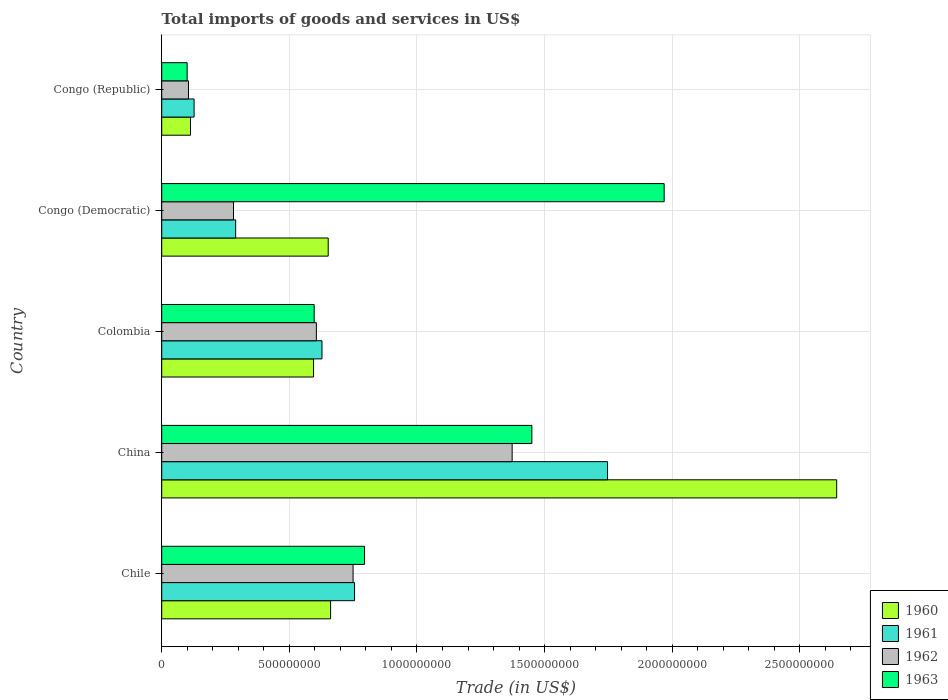How many different coloured bars are there?
Provide a short and direct response. 4. Are the number of bars on each tick of the Y-axis equal?
Provide a short and direct response. Yes. How many bars are there on the 5th tick from the top?
Provide a succinct answer. 4. What is the label of the 1st group of bars from the top?
Give a very brief answer. Congo (Republic). What is the total imports of goods and services in 1961 in China?
Make the answer very short. 1.75e+09. Across all countries, what is the maximum total imports of goods and services in 1963?
Your answer should be very brief. 1.97e+09. Across all countries, what is the minimum total imports of goods and services in 1963?
Offer a terse response. 9.96e+07. In which country was the total imports of goods and services in 1963 minimum?
Keep it short and to the point. Congo (Republic). What is the total total imports of goods and services in 1963 in the graph?
Your response must be concise. 4.91e+09. What is the difference between the total imports of goods and services in 1962 in Colombia and that in Congo (Democratic)?
Provide a succinct answer. 3.25e+08. What is the difference between the total imports of goods and services in 1962 in Congo (Democratic) and the total imports of goods and services in 1961 in Colombia?
Provide a succinct answer. -3.47e+08. What is the average total imports of goods and services in 1961 per country?
Your response must be concise. 7.09e+08. What is the difference between the total imports of goods and services in 1960 and total imports of goods and services in 1962 in Chile?
Offer a terse response. -8.81e+07. What is the ratio of the total imports of goods and services in 1962 in China to that in Congo (Republic)?
Provide a succinct answer. 13.1. Is the total imports of goods and services in 1962 in Congo (Democratic) less than that in Congo (Republic)?
Keep it short and to the point. No. What is the difference between the highest and the second highest total imports of goods and services in 1960?
Give a very brief answer. 1.98e+09. What is the difference between the highest and the lowest total imports of goods and services in 1963?
Provide a succinct answer. 1.87e+09. In how many countries, is the total imports of goods and services in 1963 greater than the average total imports of goods and services in 1963 taken over all countries?
Make the answer very short. 2. Is the sum of the total imports of goods and services in 1960 in China and Colombia greater than the maximum total imports of goods and services in 1963 across all countries?
Your answer should be very brief. Yes. What does the 4th bar from the top in Colombia represents?
Keep it short and to the point. 1960. What does the 3rd bar from the bottom in Chile represents?
Offer a terse response. 1962. Is it the case that in every country, the sum of the total imports of goods and services in 1963 and total imports of goods and services in 1960 is greater than the total imports of goods and services in 1961?
Keep it short and to the point. Yes. How many bars are there?
Your answer should be very brief. 20. What is the difference between two consecutive major ticks on the X-axis?
Keep it short and to the point. 5.00e+08. Does the graph contain any zero values?
Offer a terse response. No. Does the graph contain grids?
Offer a very short reply. Yes. How many legend labels are there?
Ensure brevity in your answer.  4. How are the legend labels stacked?
Your answer should be very brief. Vertical. What is the title of the graph?
Offer a very short reply. Total imports of goods and services in US$. Does "2002" appear as one of the legend labels in the graph?
Your answer should be compact. No. What is the label or title of the X-axis?
Keep it short and to the point. Trade (in US$). What is the Trade (in US$) in 1960 in Chile?
Ensure brevity in your answer.  6.62e+08. What is the Trade (in US$) of 1961 in Chile?
Your answer should be very brief. 7.55e+08. What is the Trade (in US$) of 1962 in Chile?
Your answer should be very brief. 7.50e+08. What is the Trade (in US$) in 1963 in Chile?
Your answer should be very brief. 7.95e+08. What is the Trade (in US$) in 1960 in China?
Ensure brevity in your answer.  2.64e+09. What is the Trade (in US$) of 1961 in China?
Your answer should be very brief. 1.75e+09. What is the Trade (in US$) of 1962 in China?
Your response must be concise. 1.37e+09. What is the Trade (in US$) in 1963 in China?
Your answer should be very brief. 1.45e+09. What is the Trade (in US$) of 1960 in Colombia?
Provide a short and direct response. 5.95e+08. What is the Trade (in US$) of 1961 in Colombia?
Make the answer very short. 6.28e+08. What is the Trade (in US$) of 1962 in Colombia?
Make the answer very short. 6.06e+08. What is the Trade (in US$) of 1963 in Colombia?
Provide a short and direct response. 5.97e+08. What is the Trade (in US$) in 1960 in Congo (Democratic)?
Offer a very short reply. 6.52e+08. What is the Trade (in US$) in 1961 in Congo (Democratic)?
Make the answer very short. 2.90e+08. What is the Trade (in US$) in 1962 in Congo (Democratic)?
Keep it short and to the point. 2.81e+08. What is the Trade (in US$) in 1963 in Congo (Democratic)?
Your answer should be compact. 1.97e+09. What is the Trade (in US$) of 1960 in Congo (Republic)?
Your answer should be compact. 1.13e+08. What is the Trade (in US$) of 1961 in Congo (Republic)?
Provide a short and direct response. 1.27e+08. What is the Trade (in US$) in 1962 in Congo (Republic)?
Keep it short and to the point. 1.05e+08. What is the Trade (in US$) in 1963 in Congo (Republic)?
Offer a very short reply. 9.96e+07. Across all countries, what is the maximum Trade (in US$) of 1960?
Your answer should be very brief. 2.64e+09. Across all countries, what is the maximum Trade (in US$) of 1961?
Ensure brevity in your answer.  1.75e+09. Across all countries, what is the maximum Trade (in US$) of 1962?
Offer a very short reply. 1.37e+09. Across all countries, what is the maximum Trade (in US$) of 1963?
Provide a succinct answer. 1.97e+09. Across all countries, what is the minimum Trade (in US$) of 1960?
Your response must be concise. 1.13e+08. Across all countries, what is the minimum Trade (in US$) of 1961?
Offer a very short reply. 1.27e+08. Across all countries, what is the minimum Trade (in US$) in 1962?
Ensure brevity in your answer.  1.05e+08. Across all countries, what is the minimum Trade (in US$) in 1963?
Give a very brief answer. 9.96e+07. What is the total Trade (in US$) in 1960 in the graph?
Your answer should be very brief. 4.67e+09. What is the total Trade (in US$) in 1961 in the graph?
Provide a short and direct response. 3.55e+09. What is the total Trade (in US$) of 1962 in the graph?
Provide a short and direct response. 3.11e+09. What is the total Trade (in US$) of 1963 in the graph?
Your answer should be compact. 4.91e+09. What is the difference between the Trade (in US$) of 1960 in Chile and that in China?
Provide a succinct answer. -1.98e+09. What is the difference between the Trade (in US$) of 1961 in Chile and that in China?
Your response must be concise. -9.91e+08. What is the difference between the Trade (in US$) in 1962 in Chile and that in China?
Provide a succinct answer. -6.23e+08. What is the difference between the Trade (in US$) in 1963 in Chile and that in China?
Give a very brief answer. -6.55e+08. What is the difference between the Trade (in US$) in 1960 in Chile and that in Colombia?
Make the answer very short. 6.68e+07. What is the difference between the Trade (in US$) of 1961 in Chile and that in Colombia?
Make the answer very short. 1.28e+08. What is the difference between the Trade (in US$) of 1962 in Chile and that in Colombia?
Your answer should be very brief. 1.44e+08. What is the difference between the Trade (in US$) in 1963 in Chile and that in Colombia?
Make the answer very short. 1.97e+08. What is the difference between the Trade (in US$) of 1960 in Chile and that in Congo (Democratic)?
Your answer should be compact. 9.37e+06. What is the difference between the Trade (in US$) in 1961 in Chile and that in Congo (Democratic)?
Give a very brief answer. 4.66e+08. What is the difference between the Trade (in US$) in 1962 in Chile and that in Congo (Democratic)?
Give a very brief answer. 4.68e+08. What is the difference between the Trade (in US$) in 1963 in Chile and that in Congo (Democratic)?
Offer a terse response. -1.17e+09. What is the difference between the Trade (in US$) of 1960 in Chile and that in Congo (Republic)?
Your response must be concise. 5.49e+08. What is the difference between the Trade (in US$) of 1961 in Chile and that in Congo (Republic)?
Ensure brevity in your answer.  6.29e+08. What is the difference between the Trade (in US$) in 1962 in Chile and that in Congo (Republic)?
Provide a succinct answer. 6.45e+08. What is the difference between the Trade (in US$) in 1963 in Chile and that in Congo (Republic)?
Ensure brevity in your answer.  6.95e+08. What is the difference between the Trade (in US$) of 1960 in China and that in Colombia?
Offer a very short reply. 2.05e+09. What is the difference between the Trade (in US$) of 1961 in China and that in Colombia?
Provide a succinct answer. 1.12e+09. What is the difference between the Trade (in US$) in 1962 in China and that in Colombia?
Give a very brief answer. 7.67e+08. What is the difference between the Trade (in US$) in 1963 in China and that in Colombia?
Your answer should be compact. 8.53e+08. What is the difference between the Trade (in US$) of 1960 in China and that in Congo (Democratic)?
Make the answer very short. 1.99e+09. What is the difference between the Trade (in US$) in 1961 in China and that in Congo (Democratic)?
Offer a terse response. 1.46e+09. What is the difference between the Trade (in US$) of 1962 in China and that in Congo (Democratic)?
Keep it short and to the point. 1.09e+09. What is the difference between the Trade (in US$) of 1963 in China and that in Congo (Democratic)?
Your response must be concise. -5.18e+08. What is the difference between the Trade (in US$) in 1960 in China and that in Congo (Republic)?
Provide a short and direct response. 2.53e+09. What is the difference between the Trade (in US$) in 1961 in China and that in Congo (Republic)?
Keep it short and to the point. 1.62e+09. What is the difference between the Trade (in US$) of 1962 in China and that in Congo (Republic)?
Provide a short and direct response. 1.27e+09. What is the difference between the Trade (in US$) of 1963 in China and that in Congo (Republic)?
Offer a terse response. 1.35e+09. What is the difference between the Trade (in US$) in 1960 in Colombia and that in Congo (Democratic)?
Offer a terse response. -5.74e+07. What is the difference between the Trade (in US$) in 1961 in Colombia and that in Congo (Democratic)?
Offer a very short reply. 3.38e+08. What is the difference between the Trade (in US$) of 1962 in Colombia and that in Congo (Democratic)?
Your answer should be very brief. 3.25e+08. What is the difference between the Trade (in US$) in 1963 in Colombia and that in Congo (Democratic)?
Keep it short and to the point. -1.37e+09. What is the difference between the Trade (in US$) of 1960 in Colombia and that in Congo (Republic)?
Provide a short and direct response. 4.82e+08. What is the difference between the Trade (in US$) of 1961 in Colombia and that in Congo (Republic)?
Provide a short and direct response. 5.01e+08. What is the difference between the Trade (in US$) in 1962 in Colombia and that in Congo (Republic)?
Your answer should be compact. 5.01e+08. What is the difference between the Trade (in US$) in 1963 in Colombia and that in Congo (Republic)?
Your answer should be very brief. 4.98e+08. What is the difference between the Trade (in US$) of 1960 in Congo (Democratic) and that in Congo (Republic)?
Give a very brief answer. 5.40e+08. What is the difference between the Trade (in US$) of 1961 in Congo (Democratic) and that in Congo (Republic)?
Provide a succinct answer. 1.63e+08. What is the difference between the Trade (in US$) in 1962 in Congo (Democratic) and that in Congo (Republic)?
Your answer should be very brief. 1.76e+08. What is the difference between the Trade (in US$) of 1963 in Congo (Democratic) and that in Congo (Republic)?
Provide a succinct answer. 1.87e+09. What is the difference between the Trade (in US$) in 1960 in Chile and the Trade (in US$) in 1961 in China?
Your answer should be very brief. -1.09e+09. What is the difference between the Trade (in US$) in 1960 in Chile and the Trade (in US$) in 1962 in China?
Provide a succinct answer. -7.11e+08. What is the difference between the Trade (in US$) of 1960 in Chile and the Trade (in US$) of 1963 in China?
Ensure brevity in your answer.  -7.88e+08. What is the difference between the Trade (in US$) of 1961 in Chile and the Trade (in US$) of 1962 in China?
Make the answer very short. -6.18e+08. What is the difference between the Trade (in US$) of 1961 in Chile and the Trade (in US$) of 1963 in China?
Ensure brevity in your answer.  -6.95e+08. What is the difference between the Trade (in US$) in 1962 in Chile and the Trade (in US$) in 1963 in China?
Provide a short and direct response. -7.00e+08. What is the difference between the Trade (in US$) of 1960 in Chile and the Trade (in US$) of 1961 in Colombia?
Offer a very short reply. 3.37e+07. What is the difference between the Trade (in US$) of 1960 in Chile and the Trade (in US$) of 1962 in Colombia?
Your answer should be compact. 5.57e+07. What is the difference between the Trade (in US$) in 1960 in Chile and the Trade (in US$) in 1963 in Colombia?
Provide a short and direct response. 6.44e+07. What is the difference between the Trade (in US$) of 1961 in Chile and the Trade (in US$) of 1962 in Colombia?
Make the answer very short. 1.50e+08. What is the difference between the Trade (in US$) in 1961 in Chile and the Trade (in US$) in 1963 in Colombia?
Ensure brevity in your answer.  1.58e+08. What is the difference between the Trade (in US$) of 1962 in Chile and the Trade (in US$) of 1963 in Colombia?
Your response must be concise. 1.52e+08. What is the difference between the Trade (in US$) of 1960 in Chile and the Trade (in US$) of 1961 in Congo (Democratic)?
Provide a succinct answer. 3.72e+08. What is the difference between the Trade (in US$) of 1960 in Chile and the Trade (in US$) of 1962 in Congo (Democratic)?
Ensure brevity in your answer.  3.80e+08. What is the difference between the Trade (in US$) in 1960 in Chile and the Trade (in US$) in 1963 in Congo (Democratic)?
Your answer should be compact. -1.31e+09. What is the difference between the Trade (in US$) of 1961 in Chile and the Trade (in US$) of 1962 in Congo (Democratic)?
Offer a terse response. 4.74e+08. What is the difference between the Trade (in US$) of 1961 in Chile and the Trade (in US$) of 1963 in Congo (Democratic)?
Make the answer very short. -1.21e+09. What is the difference between the Trade (in US$) in 1962 in Chile and the Trade (in US$) in 1963 in Congo (Democratic)?
Your answer should be very brief. -1.22e+09. What is the difference between the Trade (in US$) in 1960 in Chile and the Trade (in US$) in 1961 in Congo (Republic)?
Your answer should be compact. 5.35e+08. What is the difference between the Trade (in US$) of 1960 in Chile and the Trade (in US$) of 1962 in Congo (Republic)?
Provide a short and direct response. 5.57e+08. What is the difference between the Trade (in US$) of 1960 in Chile and the Trade (in US$) of 1963 in Congo (Republic)?
Make the answer very short. 5.62e+08. What is the difference between the Trade (in US$) of 1961 in Chile and the Trade (in US$) of 1962 in Congo (Republic)?
Your answer should be compact. 6.51e+08. What is the difference between the Trade (in US$) of 1961 in Chile and the Trade (in US$) of 1963 in Congo (Republic)?
Your response must be concise. 6.56e+08. What is the difference between the Trade (in US$) in 1962 in Chile and the Trade (in US$) in 1963 in Congo (Republic)?
Your answer should be compact. 6.50e+08. What is the difference between the Trade (in US$) in 1960 in China and the Trade (in US$) in 1961 in Colombia?
Your response must be concise. 2.02e+09. What is the difference between the Trade (in US$) in 1960 in China and the Trade (in US$) in 1962 in Colombia?
Keep it short and to the point. 2.04e+09. What is the difference between the Trade (in US$) of 1960 in China and the Trade (in US$) of 1963 in Colombia?
Provide a short and direct response. 2.05e+09. What is the difference between the Trade (in US$) in 1961 in China and the Trade (in US$) in 1962 in Colombia?
Keep it short and to the point. 1.14e+09. What is the difference between the Trade (in US$) in 1961 in China and the Trade (in US$) in 1963 in Colombia?
Ensure brevity in your answer.  1.15e+09. What is the difference between the Trade (in US$) of 1962 in China and the Trade (in US$) of 1963 in Colombia?
Keep it short and to the point. 7.76e+08. What is the difference between the Trade (in US$) in 1960 in China and the Trade (in US$) in 1961 in Congo (Democratic)?
Keep it short and to the point. 2.35e+09. What is the difference between the Trade (in US$) in 1960 in China and the Trade (in US$) in 1962 in Congo (Democratic)?
Ensure brevity in your answer.  2.36e+09. What is the difference between the Trade (in US$) in 1960 in China and the Trade (in US$) in 1963 in Congo (Democratic)?
Make the answer very short. 6.76e+08. What is the difference between the Trade (in US$) in 1961 in China and the Trade (in US$) in 1962 in Congo (Democratic)?
Offer a very short reply. 1.47e+09. What is the difference between the Trade (in US$) in 1961 in China and the Trade (in US$) in 1963 in Congo (Democratic)?
Ensure brevity in your answer.  -2.22e+08. What is the difference between the Trade (in US$) of 1962 in China and the Trade (in US$) of 1963 in Congo (Democratic)?
Your response must be concise. -5.96e+08. What is the difference between the Trade (in US$) in 1960 in China and the Trade (in US$) in 1961 in Congo (Republic)?
Provide a short and direct response. 2.52e+09. What is the difference between the Trade (in US$) of 1960 in China and the Trade (in US$) of 1962 in Congo (Republic)?
Provide a succinct answer. 2.54e+09. What is the difference between the Trade (in US$) of 1960 in China and the Trade (in US$) of 1963 in Congo (Republic)?
Ensure brevity in your answer.  2.54e+09. What is the difference between the Trade (in US$) of 1961 in China and the Trade (in US$) of 1962 in Congo (Republic)?
Ensure brevity in your answer.  1.64e+09. What is the difference between the Trade (in US$) of 1961 in China and the Trade (in US$) of 1963 in Congo (Republic)?
Your answer should be compact. 1.65e+09. What is the difference between the Trade (in US$) in 1962 in China and the Trade (in US$) in 1963 in Congo (Republic)?
Provide a short and direct response. 1.27e+09. What is the difference between the Trade (in US$) of 1960 in Colombia and the Trade (in US$) of 1961 in Congo (Democratic)?
Provide a short and direct response. 3.05e+08. What is the difference between the Trade (in US$) in 1960 in Colombia and the Trade (in US$) in 1962 in Congo (Democratic)?
Your response must be concise. 3.14e+08. What is the difference between the Trade (in US$) of 1960 in Colombia and the Trade (in US$) of 1963 in Congo (Democratic)?
Ensure brevity in your answer.  -1.37e+09. What is the difference between the Trade (in US$) of 1961 in Colombia and the Trade (in US$) of 1962 in Congo (Democratic)?
Make the answer very short. 3.47e+08. What is the difference between the Trade (in US$) of 1961 in Colombia and the Trade (in US$) of 1963 in Congo (Democratic)?
Ensure brevity in your answer.  -1.34e+09. What is the difference between the Trade (in US$) in 1962 in Colombia and the Trade (in US$) in 1963 in Congo (Democratic)?
Provide a succinct answer. -1.36e+09. What is the difference between the Trade (in US$) in 1960 in Colombia and the Trade (in US$) in 1961 in Congo (Republic)?
Offer a very short reply. 4.68e+08. What is the difference between the Trade (in US$) of 1960 in Colombia and the Trade (in US$) of 1962 in Congo (Republic)?
Offer a terse response. 4.90e+08. What is the difference between the Trade (in US$) in 1960 in Colombia and the Trade (in US$) in 1963 in Congo (Republic)?
Give a very brief answer. 4.95e+08. What is the difference between the Trade (in US$) in 1961 in Colombia and the Trade (in US$) in 1962 in Congo (Republic)?
Offer a terse response. 5.23e+08. What is the difference between the Trade (in US$) in 1961 in Colombia and the Trade (in US$) in 1963 in Congo (Republic)?
Provide a succinct answer. 5.28e+08. What is the difference between the Trade (in US$) of 1962 in Colombia and the Trade (in US$) of 1963 in Congo (Republic)?
Your answer should be compact. 5.06e+08. What is the difference between the Trade (in US$) in 1960 in Congo (Democratic) and the Trade (in US$) in 1961 in Congo (Republic)?
Ensure brevity in your answer.  5.25e+08. What is the difference between the Trade (in US$) in 1960 in Congo (Democratic) and the Trade (in US$) in 1962 in Congo (Republic)?
Ensure brevity in your answer.  5.47e+08. What is the difference between the Trade (in US$) in 1960 in Congo (Democratic) and the Trade (in US$) in 1963 in Congo (Republic)?
Keep it short and to the point. 5.53e+08. What is the difference between the Trade (in US$) of 1961 in Congo (Democratic) and the Trade (in US$) of 1962 in Congo (Republic)?
Provide a short and direct response. 1.85e+08. What is the difference between the Trade (in US$) of 1961 in Congo (Democratic) and the Trade (in US$) of 1963 in Congo (Republic)?
Give a very brief answer. 1.90e+08. What is the difference between the Trade (in US$) in 1962 in Congo (Democratic) and the Trade (in US$) in 1963 in Congo (Republic)?
Offer a very short reply. 1.82e+08. What is the average Trade (in US$) of 1960 per country?
Your answer should be compact. 9.33e+08. What is the average Trade (in US$) of 1961 per country?
Your response must be concise. 7.09e+08. What is the average Trade (in US$) in 1962 per country?
Make the answer very short. 6.23e+08. What is the average Trade (in US$) of 1963 per country?
Offer a terse response. 9.82e+08. What is the difference between the Trade (in US$) of 1960 and Trade (in US$) of 1961 in Chile?
Provide a short and direct response. -9.38e+07. What is the difference between the Trade (in US$) in 1960 and Trade (in US$) in 1962 in Chile?
Make the answer very short. -8.81e+07. What is the difference between the Trade (in US$) in 1960 and Trade (in US$) in 1963 in Chile?
Offer a terse response. -1.33e+08. What is the difference between the Trade (in US$) of 1961 and Trade (in US$) of 1962 in Chile?
Give a very brief answer. 5.71e+06. What is the difference between the Trade (in US$) of 1961 and Trade (in US$) of 1963 in Chile?
Your response must be concise. -3.92e+07. What is the difference between the Trade (in US$) in 1962 and Trade (in US$) in 1963 in Chile?
Offer a very short reply. -4.50e+07. What is the difference between the Trade (in US$) of 1960 and Trade (in US$) of 1961 in China?
Provide a short and direct response. 8.98e+08. What is the difference between the Trade (in US$) in 1960 and Trade (in US$) in 1962 in China?
Provide a short and direct response. 1.27e+09. What is the difference between the Trade (in US$) in 1960 and Trade (in US$) in 1963 in China?
Provide a succinct answer. 1.19e+09. What is the difference between the Trade (in US$) of 1961 and Trade (in US$) of 1962 in China?
Your answer should be very brief. 3.74e+08. What is the difference between the Trade (in US$) in 1961 and Trade (in US$) in 1963 in China?
Offer a very short reply. 2.97e+08. What is the difference between the Trade (in US$) in 1962 and Trade (in US$) in 1963 in China?
Your response must be concise. -7.72e+07. What is the difference between the Trade (in US$) in 1960 and Trade (in US$) in 1961 in Colombia?
Offer a terse response. -3.30e+07. What is the difference between the Trade (in US$) of 1960 and Trade (in US$) of 1962 in Colombia?
Make the answer very short. -1.10e+07. What is the difference between the Trade (in US$) of 1960 and Trade (in US$) of 1963 in Colombia?
Provide a short and direct response. -2.39e+06. What is the difference between the Trade (in US$) in 1961 and Trade (in US$) in 1962 in Colombia?
Make the answer very short. 2.20e+07. What is the difference between the Trade (in US$) of 1961 and Trade (in US$) of 1963 in Colombia?
Provide a short and direct response. 3.06e+07. What is the difference between the Trade (in US$) of 1962 and Trade (in US$) of 1963 in Colombia?
Keep it short and to the point. 8.64e+06. What is the difference between the Trade (in US$) in 1960 and Trade (in US$) in 1961 in Congo (Democratic)?
Provide a short and direct response. 3.63e+08. What is the difference between the Trade (in US$) in 1960 and Trade (in US$) in 1962 in Congo (Democratic)?
Give a very brief answer. 3.71e+08. What is the difference between the Trade (in US$) of 1960 and Trade (in US$) of 1963 in Congo (Democratic)?
Offer a very short reply. -1.32e+09. What is the difference between the Trade (in US$) of 1961 and Trade (in US$) of 1962 in Congo (Democratic)?
Keep it short and to the point. 8.49e+06. What is the difference between the Trade (in US$) in 1961 and Trade (in US$) in 1963 in Congo (Democratic)?
Offer a very short reply. -1.68e+09. What is the difference between the Trade (in US$) in 1962 and Trade (in US$) in 1963 in Congo (Democratic)?
Your response must be concise. -1.69e+09. What is the difference between the Trade (in US$) in 1960 and Trade (in US$) in 1961 in Congo (Republic)?
Provide a short and direct response. -1.41e+07. What is the difference between the Trade (in US$) of 1960 and Trade (in US$) of 1962 in Congo (Republic)?
Keep it short and to the point. 7.94e+06. What is the difference between the Trade (in US$) of 1960 and Trade (in US$) of 1963 in Congo (Republic)?
Keep it short and to the point. 1.31e+07. What is the difference between the Trade (in US$) in 1961 and Trade (in US$) in 1962 in Congo (Republic)?
Your answer should be very brief. 2.21e+07. What is the difference between the Trade (in US$) in 1961 and Trade (in US$) in 1963 in Congo (Republic)?
Your answer should be compact. 2.73e+07. What is the difference between the Trade (in US$) of 1962 and Trade (in US$) of 1963 in Congo (Republic)?
Make the answer very short. 5.20e+06. What is the ratio of the Trade (in US$) of 1960 in Chile to that in China?
Offer a very short reply. 0.25. What is the ratio of the Trade (in US$) of 1961 in Chile to that in China?
Ensure brevity in your answer.  0.43. What is the ratio of the Trade (in US$) of 1962 in Chile to that in China?
Provide a succinct answer. 0.55. What is the ratio of the Trade (in US$) of 1963 in Chile to that in China?
Your response must be concise. 0.55. What is the ratio of the Trade (in US$) in 1960 in Chile to that in Colombia?
Offer a terse response. 1.11. What is the ratio of the Trade (in US$) in 1961 in Chile to that in Colombia?
Your answer should be compact. 1.2. What is the ratio of the Trade (in US$) of 1962 in Chile to that in Colombia?
Make the answer very short. 1.24. What is the ratio of the Trade (in US$) of 1963 in Chile to that in Colombia?
Give a very brief answer. 1.33. What is the ratio of the Trade (in US$) of 1960 in Chile to that in Congo (Democratic)?
Your answer should be compact. 1.01. What is the ratio of the Trade (in US$) of 1961 in Chile to that in Congo (Democratic)?
Provide a succinct answer. 2.61. What is the ratio of the Trade (in US$) in 1962 in Chile to that in Congo (Democratic)?
Provide a succinct answer. 2.67. What is the ratio of the Trade (in US$) in 1963 in Chile to that in Congo (Democratic)?
Your answer should be very brief. 0.4. What is the ratio of the Trade (in US$) in 1960 in Chile to that in Congo (Republic)?
Your answer should be very brief. 5.87. What is the ratio of the Trade (in US$) in 1961 in Chile to that in Congo (Republic)?
Your response must be concise. 5.95. What is the ratio of the Trade (in US$) of 1962 in Chile to that in Congo (Republic)?
Give a very brief answer. 7.15. What is the ratio of the Trade (in US$) of 1963 in Chile to that in Congo (Republic)?
Your response must be concise. 7.98. What is the ratio of the Trade (in US$) of 1960 in China to that in Colombia?
Your answer should be compact. 4.45. What is the ratio of the Trade (in US$) in 1961 in China to that in Colombia?
Ensure brevity in your answer.  2.78. What is the ratio of the Trade (in US$) in 1962 in China to that in Colombia?
Provide a succinct answer. 2.27. What is the ratio of the Trade (in US$) of 1963 in China to that in Colombia?
Ensure brevity in your answer.  2.43. What is the ratio of the Trade (in US$) of 1960 in China to that in Congo (Democratic)?
Give a very brief answer. 4.05. What is the ratio of the Trade (in US$) of 1961 in China to that in Congo (Democratic)?
Provide a short and direct response. 6.03. What is the ratio of the Trade (in US$) in 1962 in China to that in Congo (Democratic)?
Offer a terse response. 4.88. What is the ratio of the Trade (in US$) of 1963 in China to that in Congo (Democratic)?
Offer a terse response. 0.74. What is the ratio of the Trade (in US$) of 1960 in China to that in Congo (Republic)?
Give a very brief answer. 23.45. What is the ratio of the Trade (in US$) in 1961 in China to that in Congo (Republic)?
Your response must be concise. 13.76. What is the ratio of the Trade (in US$) of 1962 in China to that in Congo (Republic)?
Make the answer very short. 13.1. What is the ratio of the Trade (in US$) of 1963 in China to that in Congo (Republic)?
Provide a succinct answer. 14.55. What is the ratio of the Trade (in US$) in 1960 in Colombia to that in Congo (Democratic)?
Make the answer very short. 0.91. What is the ratio of the Trade (in US$) in 1961 in Colombia to that in Congo (Democratic)?
Ensure brevity in your answer.  2.17. What is the ratio of the Trade (in US$) in 1962 in Colombia to that in Congo (Democratic)?
Your answer should be compact. 2.15. What is the ratio of the Trade (in US$) in 1963 in Colombia to that in Congo (Democratic)?
Your response must be concise. 0.3. What is the ratio of the Trade (in US$) of 1960 in Colombia to that in Congo (Republic)?
Your answer should be very brief. 5.28. What is the ratio of the Trade (in US$) of 1961 in Colombia to that in Congo (Republic)?
Your answer should be compact. 4.95. What is the ratio of the Trade (in US$) in 1962 in Colombia to that in Congo (Republic)?
Your response must be concise. 5.78. What is the ratio of the Trade (in US$) of 1963 in Colombia to that in Congo (Republic)?
Give a very brief answer. 5.99. What is the ratio of the Trade (in US$) in 1960 in Congo (Democratic) to that in Congo (Republic)?
Your answer should be compact. 5.78. What is the ratio of the Trade (in US$) of 1961 in Congo (Democratic) to that in Congo (Republic)?
Your answer should be compact. 2.28. What is the ratio of the Trade (in US$) in 1962 in Congo (Democratic) to that in Congo (Republic)?
Ensure brevity in your answer.  2.68. What is the ratio of the Trade (in US$) in 1963 in Congo (Democratic) to that in Congo (Republic)?
Your answer should be compact. 19.76. What is the difference between the highest and the second highest Trade (in US$) of 1960?
Your answer should be very brief. 1.98e+09. What is the difference between the highest and the second highest Trade (in US$) of 1961?
Your answer should be very brief. 9.91e+08. What is the difference between the highest and the second highest Trade (in US$) in 1962?
Ensure brevity in your answer.  6.23e+08. What is the difference between the highest and the second highest Trade (in US$) in 1963?
Offer a very short reply. 5.18e+08. What is the difference between the highest and the lowest Trade (in US$) of 1960?
Give a very brief answer. 2.53e+09. What is the difference between the highest and the lowest Trade (in US$) in 1961?
Offer a terse response. 1.62e+09. What is the difference between the highest and the lowest Trade (in US$) in 1962?
Ensure brevity in your answer.  1.27e+09. What is the difference between the highest and the lowest Trade (in US$) in 1963?
Your answer should be compact. 1.87e+09. 